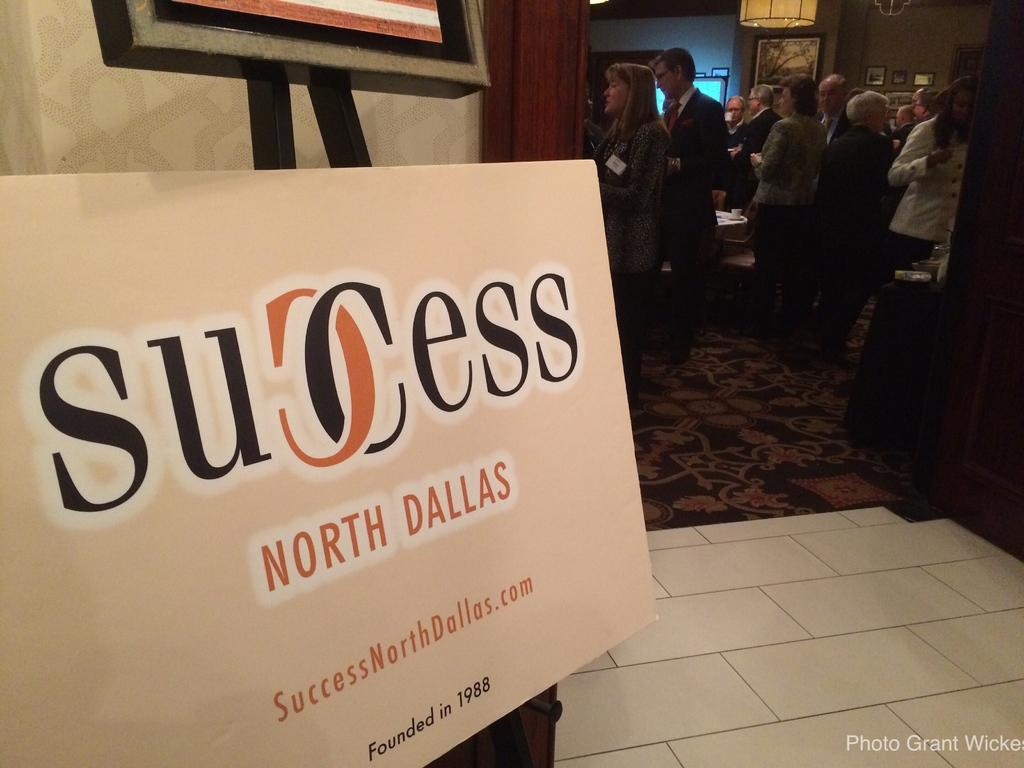What is located at the front of the image? There is a board in the front of the image. Where are the people positioned in the image? People are standing at the back of the image. What can be seen on the walls in the image? There are photo frames on the walls in the image. What type of business is being started in the image? There is no indication of a business being started in the image. Who is the expert standing at the back of the image? There is no expert mentioned or visible in the image. 